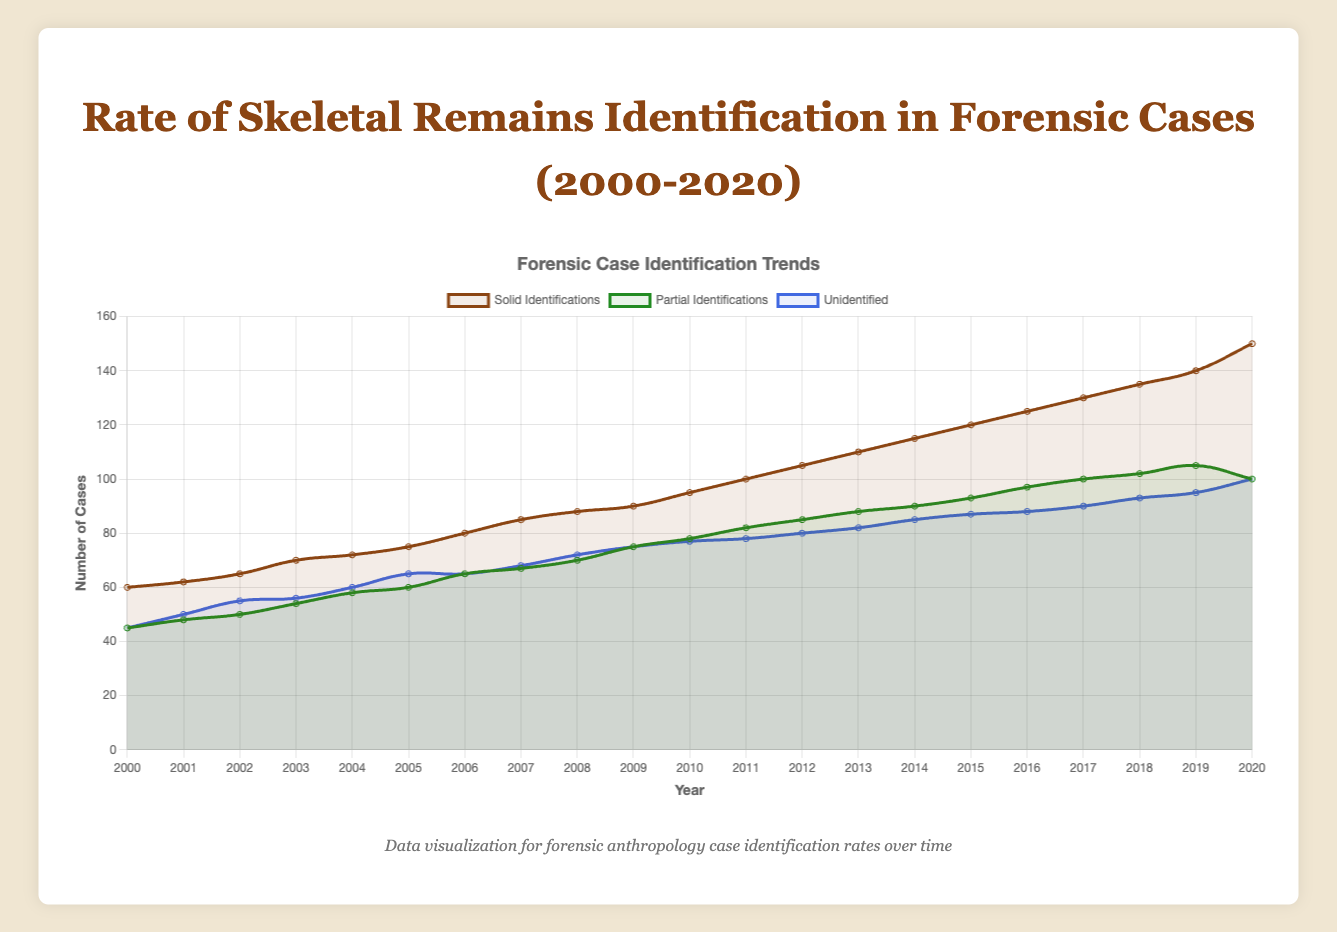What is the trend in the number of solid identifications from 2000 to 2020? The trend in the number of solid identifications increases over time. In 2000, it starts at 60 and gradually rises to 150 by 2020. This increase is visually represented by the upward-sloping orange line on the plot.
Answer: Increasing trend In which year did the solid identifications first reach 100 cases? By looking at the solid orange line, the number of solid identifications reaches 100 cases in the year 2011. This is identified by the intersection of the orange line with the 100-case mark on the y-axis.
Answer: 2011 How many more cases were examined in 2020 compared to 2000? In 2000, 150 cases were examined, and in 2020, 350 cases were examined. The difference can be calculated as 350 - 150 = 200.
Answer: 200 cases In which year did the number of unidentified cases first surpass 80? The blue line, representing unidentified cases, first reaches above 80 cases in 2012. This can be identified by finding where the blue line crosses the 80-case mark on the y-axis in that period.
Answer: 2012 What is the total sum of solid identifications and partial identifications in 2018? In 2018, solid identifications are 135, and partial identifications are 102. Summing these gives 135 + 102 = 237.
Answer: 237 How does the trend in partial identifications compare to the trend in solid identifications over the given period? Both solid and partial identifications show an overall increasing trend over the years. However, the solid identifications increase at a faster and more consistent rate compared to partial identifications, which show a slight dip and more variability in the later years.
Answer: Faster and more consistent increase in solid identifications Which type of identification had the largest increase from 2000 to 2020? To determine this, compare the increase in solid identifications (from 60 to 150), partial identifications (from 45 to 100), and unidentified cases (from 45 to 100). The increase in solid identifications is 150 - 60 = 90. For partial, it's 100 - 45 = 55. For unidentified, it's 100 - 45 = 55. Solid identifications have the largest increase of 90 cases.
Answer: Solid identifications What is the percentage increase in the number of cases examined from 2000 to 2020? The number of cases examined in 2000 was 150, and in 2020 it was 350. The percentage increase can be calculated by (350 - 150) / 150 * 100 = 133.33%.
Answer: 133.33% In which years did the number of unidentified cases remain constant? The blue line representing unidentified cases remains constant at 65 cases from 2005 to 2006, indicating no change in those years.
Answer: 2005-2006 